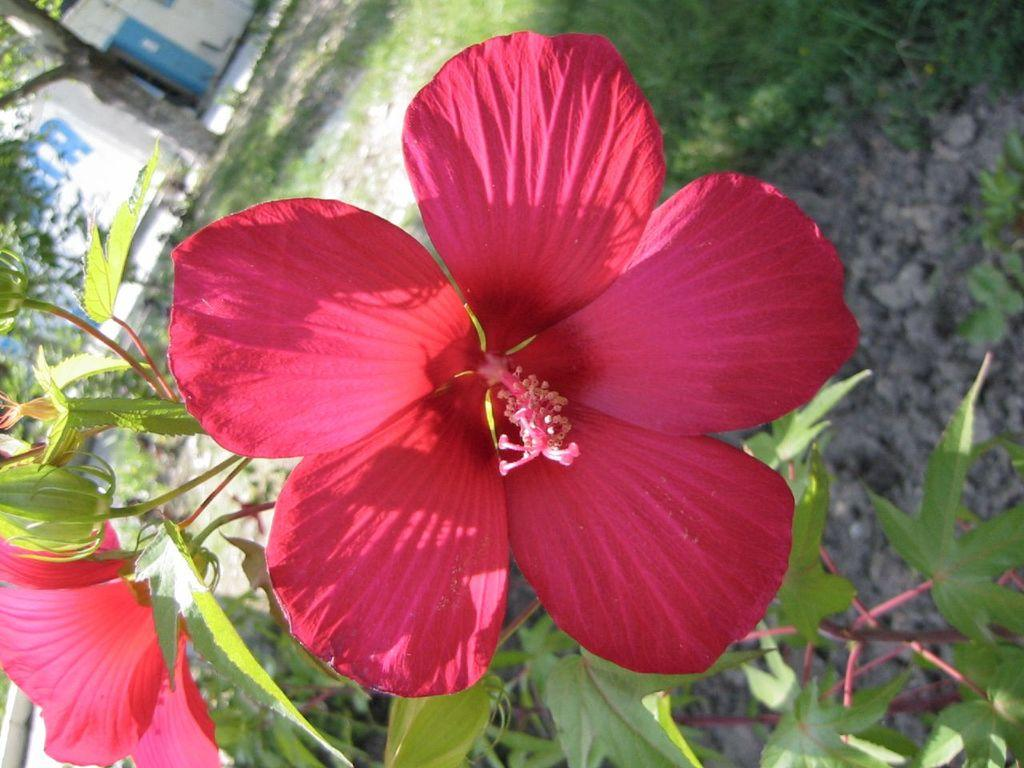What type of plant is in the image? There is a plant with hibiscus flowers in the image. What stage of growth are the flowers on the plant in? There are buds on the plant. What else can be seen on the plant besides flowers? There are leaves on the plant. What is visible on the ground in the image? There is grass on the ground. What can be seen in the background of the image? There is a tree and a wall in the background of the image. How does the yam contribute to the growth of the hibiscus plant in the image? There is no yam present in the image, and therefore it cannot contribute to the growth of the hibiscus plant. 